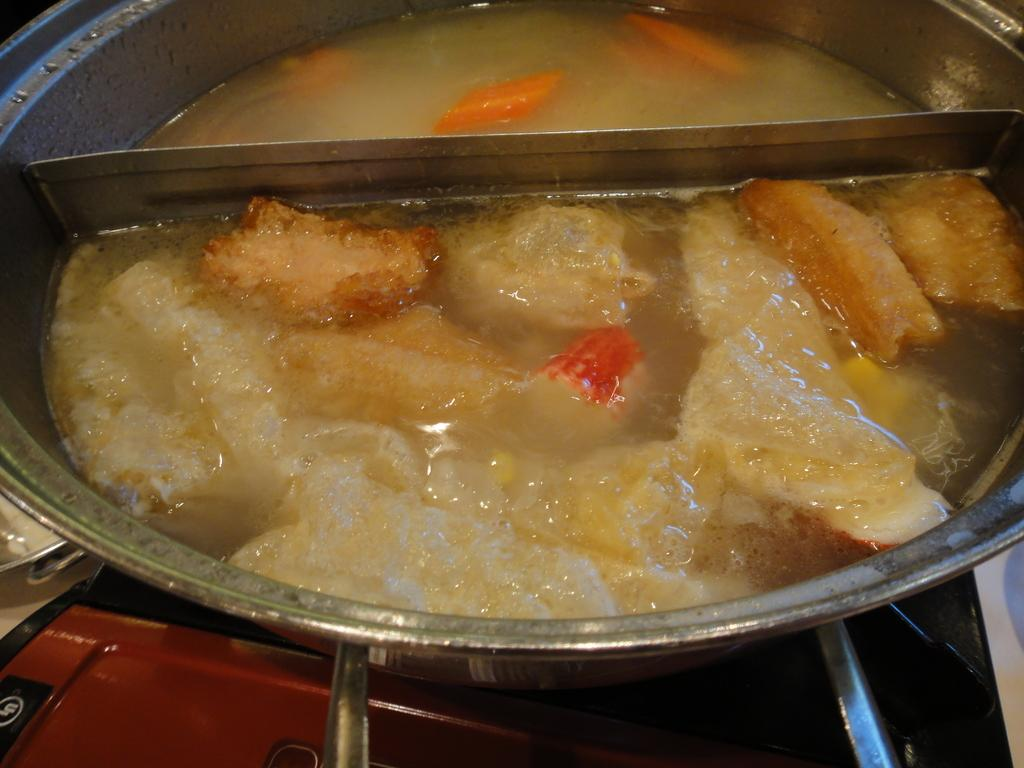What is in the container that is visible in the image? There is a container with food in the image. Where is the container located in the image? The container is on a stove. How does the baby in the image get the attention of the cook? There is no baby present in the image; it only features a container with food on a stove. 